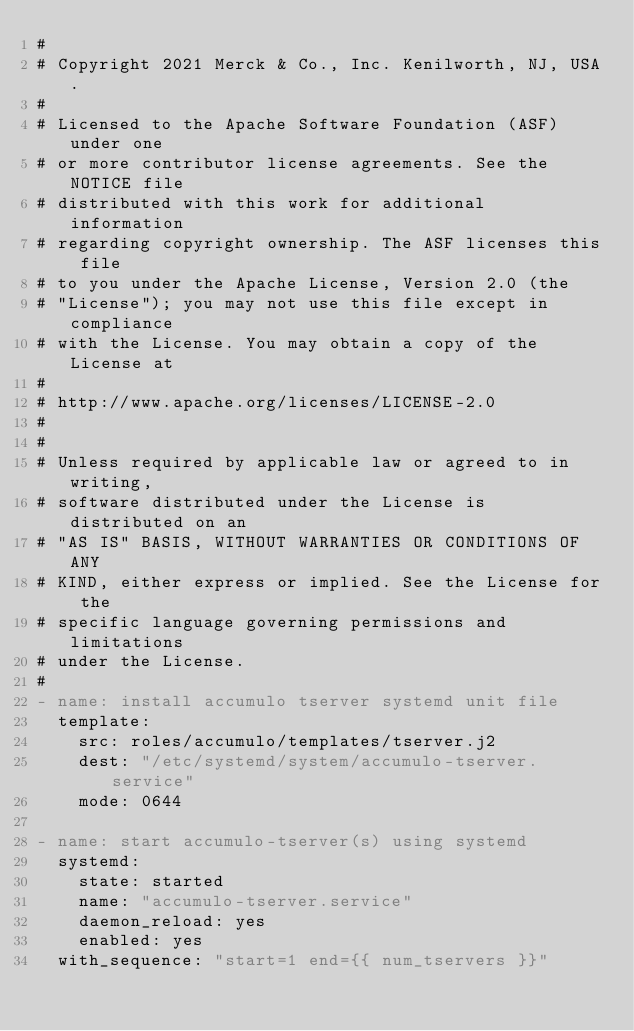<code> <loc_0><loc_0><loc_500><loc_500><_YAML_>#
# Copyright 2021 Merck & Co., Inc. Kenilworth, NJ, USA.
#
#	Licensed to the Apache Software Foundation (ASF) under one
#	or more contributor license agreements. See the NOTICE file
#	distributed with this work for additional information
#	regarding copyright ownership. The ASF licenses this file
#	to you under the Apache License, Version 2.0 (the
#	"License"); you may not use this file except in compliance
#	with the License. You may obtain a copy of the License at
#
#	http://www.apache.org/licenses/LICENSE-2.0
#
#
#	Unless required by applicable law or agreed to in writing,
#	software distributed under the License is distributed on an
#	"AS IS" BASIS, WITHOUT WARRANTIES OR CONDITIONS OF ANY
#	KIND, either express or implied. See the License for the
#	specific language governing permissions and limitations
#	under the License.
#
- name: install accumulo tserver systemd unit file
  template:
    src: roles/accumulo/templates/tserver.j2
    dest: "/etc/systemd/system/accumulo-tserver.service"
    mode: 0644

- name: start accumulo-tserver(s) using systemd
  systemd:
    state: started
    name: "accumulo-tserver.service"
    daemon_reload: yes
    enabled: yes
  with_sequence: "start=1 end={{ num_tservers }}"
</code> 